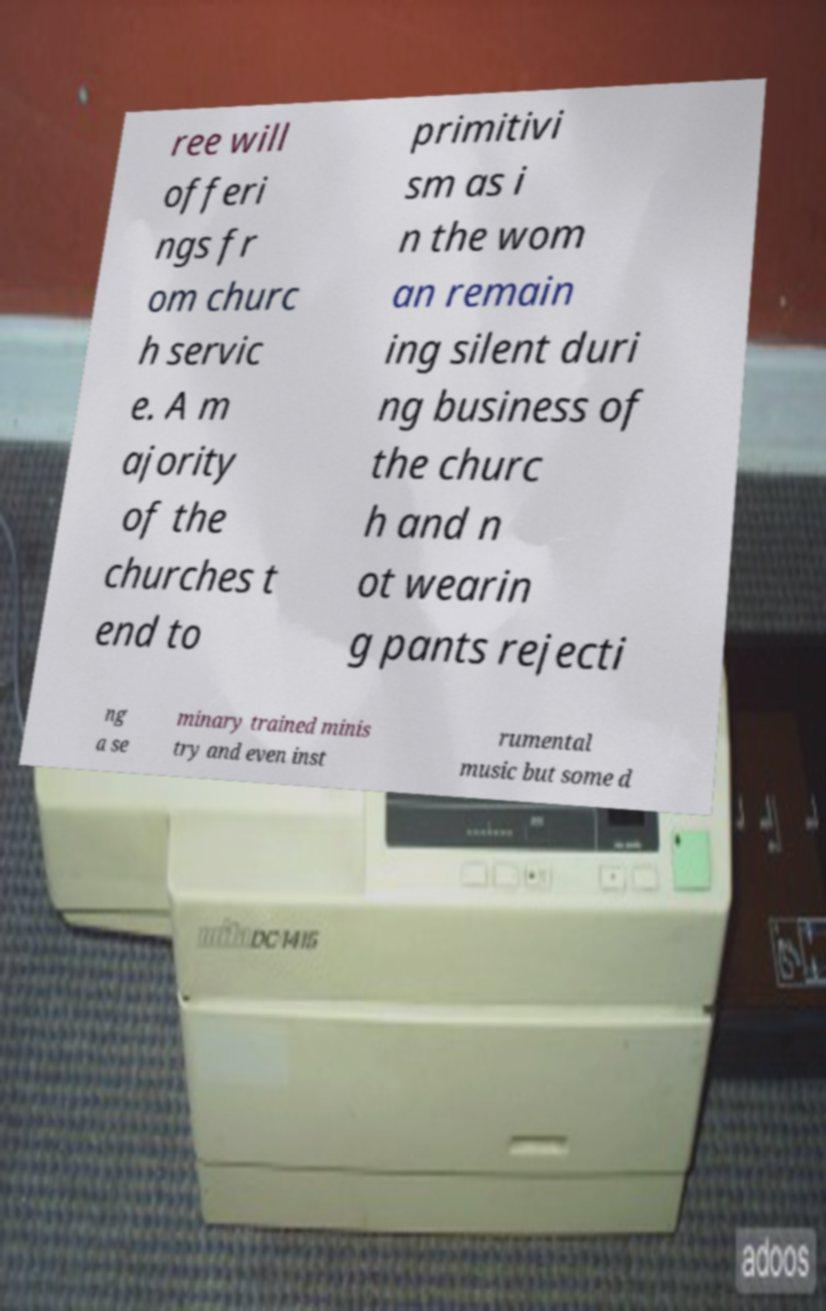Can you read and provide the text displayed in the image?This photo seems to have some interesting text. Can you extract and type it out for me? ree will offeri ngs fr om churc h servic e. A m ajority of the churches t end to primitivi sm as i n the wom an remain ing silent duri ng business of the churc h and n ot wearin g pants rejecti ng a se minary trained minis try and even inst rumental music but some d 